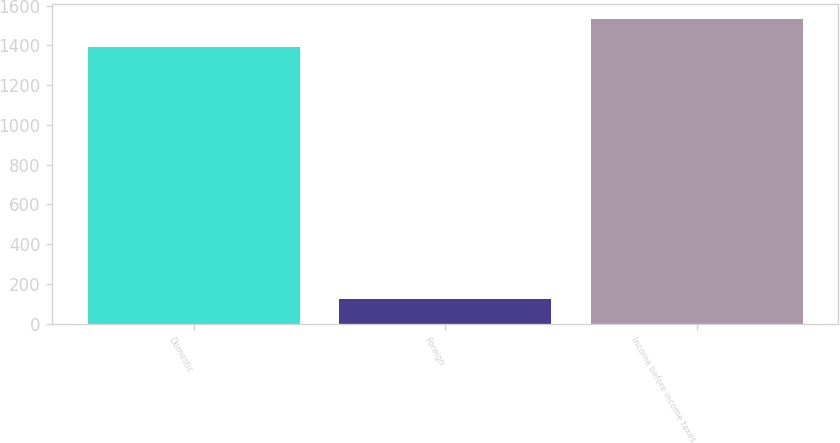Convert chart. <chart><loc_0><loc_0><loc_500><loc_500><bar_chart><fcel>Domestic<fcel>Foreign<fcel>Income before income taxes<nl><fcel>1394<fcel>126<fcel>1533.4<nl></chart> 